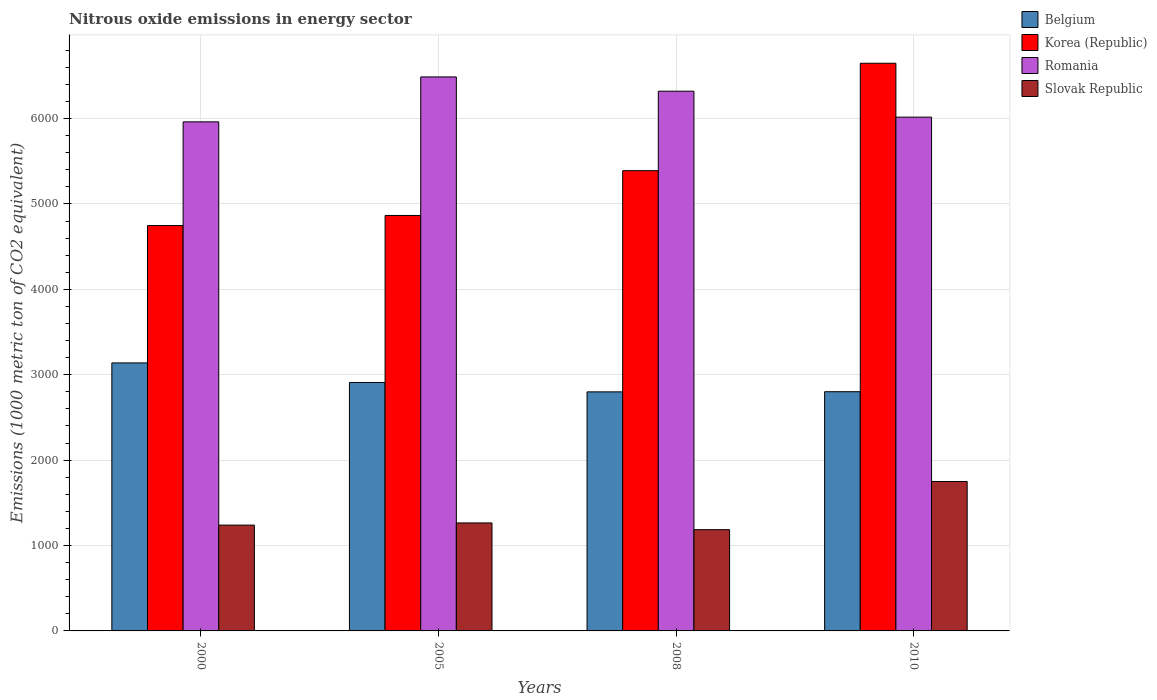Are the number of bars per tick equal to the number of legend labels?
Your response must be concise. Yes. How many bars are there on the 4th tick from the left?
Your answer should be compact. 4. How many bars are there on the 3rd tick from the right?
Provide a succinct answer. 4. What is the label of the 3rd group of bars from the left?
Your answer should be very brief. 2008. What is the amount of nitrous oxide emitted in Slovak Republic in 2000?
Offer a terse response. 1239.1. Across all years, what is the maximum amount of nitrous oxide emitted in Romania?
Your response must be concise. 6487.3. Across all years, what is the minimum amount of nitrous oxide emitted in Romania?
Offer a terse response. 5961.2. In which year was the amount of nitrous oxide emitted in Belgium maximum?
Offer a terse response. 2000. What is the total amount of nitrous oxide emitted in Belgium in the graph?
Your response must be concise. 1.16e+04. What is the difference between the amount of nitrous oxide emitted in Romania in 2000 and that in 2008?
Your answer should be compact. -358.9. What is the difference between the amount of nitrous oxide emitted in Slovak Republic in 2008 and the amount of nitrous oxide emitted in Belgium in 2000?
Make the answer very short. -1952.9. What is the average amount of nitrous oxide emitted in Slovak Republic per year?
Make the answer very short. 1359.7. In the year 2008, what is the difference between the amount of nitrous oxide emitted in Korea (Republic) and amount of nitrous oxide emitted in Belgium?
Your answer should be compact. 2590.3. In how many years, is the amount of nitrous oxide emitted in Korea (Republic) greater than 800 1000 metric ton?
Give a very brief answer. 4. What is the ratio of the amount of nitrous oxide emitted in Romania in 2000 to that in 2010?
Make the answer very short. 0.99. Is the difference between the amount of nitrous oxide emitted in Korea (Republic) in 2000 and 2008 greater than the difference between the amount of nitrous oxide emitted in Belgium in 2000 and 2008?
Make the answer very short. No. What is the difference between the highest and the second highest amount of nitrous oxide emitted in Korea (Republic)?
Make the answer very short. 1257.7. What is the difference between the highest and the lowest amount of nitrous oxide emitted in Slovak Republic?
Keep it short and to the point. 564.2. Is it the case that in every year, the sum of the amount of nitrous oxide emitted in Korea (Republic) and amount of nitrous oxide emitted in Belgium is greater than the sum of amount of nitrous oxide emitted in Slovak Republic and amount of nitrous oxide emitted in Romania?
Your answer should be very brief. Yes. What does the 1st bar from the left in 2008 represents?
Your response must be concise. Belgium. What does the 3rd bar from the right in 2008 represents?
Keep it short and to the point. Korea (Republic). Is it the case that in every year, the sum of the amount of nitrous oxide emitted in Romania and amount of nitrous oxide emitted in Belgium is greater than the amount of nitrous oxide emitted in Slovak Republic?
Give a very brief answer. Yes. How many bars are there?
Make the answer very short. 16. How many years are there in the graph?
Keep it short and to the point. 4. Are the values on the major ticks of Y-axis written in scientific E-notation?
Your response must be concise. No. Where does the legend appear in the graph?
Ensure brevity in your answer.  Top right. How many legend labels are there?
Provide a short and direct response. 4. What is the title of the graph?
Provide a short and direct response. Nitrous oxide emissions in energy sector. What is the label or title of the X-axis?
Your answer should be compact. Years. What is the label or title of the Y-axis?
Provide a succinct answer. Emissions (1000 metric ton of CO2 equivalent). What is the Emissions (1000 metric ton of CO2 equivalent) of Belgium in 2000?
Provide a short and direct response. 3138.4. What is the Emissions (1000 metric ton of CO2 equivalent) of Korea (Republic) in 2000?
Provide a succinct answer. 4746.8. What is the Emissions (1000 metric ton of CO2 equivalent) of Romania in 2000?
Your answer should be very brief. 5961.2. What is the Emissions (1000 metric ton of CO2 equivalent) in Slovak Republic in 2000?
Ensure brevity in your answer.  1239.1. What is the Emissions (1000 metric ton of CO2 equivalent) of Belgium in 2005?
Your answer should be compact. 2909.4. What is the Emissions (1000 metric ton of CO2 equivalent) of Korea (Republic) in 2005?
Your answer should be compact. 4865. What is the Emissions (1000 metric ton of CO2 equivalent) of Romania in 2005?
Keep it short and to the point. 6487.3. What is the Emissions (1000 metric ton of CO2 equivalent) in Slovak Republic in 2005?
Your response must be concise. 1264.5. What is the Emissions (1000 metric ton of CO2 equivalent) of Belgium in 2008?
Your answer should be compact. 2799.3. What is the Emissions (1000 metric ton of CO2 equivalent) in Korea (Republic) in 2008?
Provide a succinct answer. 5389.6. What is the Emissions (1000 metric ton of CO2 equivalent) of Romania in 2008?
Offer a terse response. 6320.1. What is the Emissions (1000 metric ton of CO2 equivalent) of Slovak Republic in 2008?
Offer a terse response. 1185.5. What is the Emissions (1000 metric ton of CO2 equivalent) of Belgium in 2010?
Your answer should be very brief. 2801.2. What is the Emissions (1000 metric ton of CO2 equivalent) in Korea (Republic) in 2010?
Give a very brief answer. 6647.3. What is the Emissions (1000 metric ton of CO2 equivalent) in Romania in 2010?
Your response must be concise. 6016.4. What is the Emissions (1000 metric ton of CO2 equivalent) in Slovak Republic in 2010?
Make the answer very short. 1749.7. Across all years, what is the maximum Emissions (1000 metric ton of CO2 equivalent) of Belgium?
Make the answer very short. 3138.4. Across all years, what is the maximum Emissions (1000 metric ton of CO2 equivalent) in Korea (Republic)?
Make the answer very short. 6647.3. Across all years, what is the maximum Emissions (1000 metric ton of CO2 equivalent) of Romania?
Provide a short and direct response. 6487.3. Across all years, what is the maximum Emissions (1000 metric ton of CO2 equivalent) of Slovak Republic?
Provide a succinct answer. 1749.7. Across all years, what is the minimum Emissions (1000 metric ton of CO2 equivalent) in Belgium?
Offer a terse response. 2799.3. Across all years, what is the minimum Emissions (1000 metric ton of CO2 equivalent) of Korea (Republic)?
Your answer should be compact. 4746.8. Across all years, what is the minimum Emissions (1000 metric ton of CO2 equivalent) in Romania?
Your answer should be compact. 5961.2. Across all years, what is the minimum Emissions (1000 metric ton of CO2 equivalent) of Slovak Republic?
Ensure brevity in your answer.  1185.5. What is the total Emissions (1000 metric ton of CO2 equivalent) of Belgium in the graph?
Offer a terse response. 1.16e+04. What is the total Emissions (1000 metric ton of CO2 equivalent) in Korea (Republic) in the graph?
Offer a terse response. 2.16e+04. What is the total Emissions (1000 metric ton of CO2 equivalent) in Romania in the graph?
Offer a terse response. 2.48e+04. What is the total Emissions (1000 metric ton of CO2 equivalent) of Slovak Republic in the graph?
Provide a short and direct response. 5438.8. What is the difference between the Emissions (1000 metric ton of CO2 equivalent) in Belgium in 2000 and that in 2005?
Your response must be concise. 229. What is the difference between the Emissions (1000 metric ton of CO2 equivalent) in Korea (Republic) in 2000 and that in 2005?
Your response must be concise. -118.2. What is the difference between the Emissions (1000 metric ton of CO2 equivalent) in Romania in 2000 and that in 2005?
Ensure brevity in your answer.  -526.1. What is the difference between the Emissions (1000 metric ton of CO2 equivalent) of Slovak Republic in 2000 and that in 2005?
Offer a very short reply. -25.4. What is the difference between the Emissions (1000 metric ton of CO2 equivalent) of Belgium in 2000 and that in 2008?
Offer a terse response. 339.1. What is the difference between the Emissions (1000 metric ton of CO2 equivalent) of Korea (Republic) in 2000 and that in 2008?
Your answer should be very brief. -642.8. What is the difference between the Emissions (1000 metric ton of CO2 equivalent) in Romania in 2000 and that in 2008?
Offer a very short reply. -358.9. What is the difference between the Emissions (1000 metric ton of CO2 equivalent) in Slovak Republic in 2000 and that in 2008?
Your response must be concise. 53.6. What is the difference between the Emissions (1000 metric ton of CO2 equivalent) in Belgium in 2000 and that in 2010?
Keep it short and to the point. 337.2. What is the difference between the Emissions (1000 metric ton of CO2 equivalent) of Korea (Republic) in 2000 and that in 2010?
Provide a succinct answer. -1900.5. What is the difference between the Emissions (1000 metric ton of CO2 equivalent) in Romania in 2000 and that in 2010?
Provide a short and direct response. -55.2. What is the difference between the Emissions (1000 metric ton of CO2 equivalent) of Slovak Republic in 2000 and that in 2010?
Make the answer very short. -510.6. What is the difference between the Emissions (1000 metric ton of CO2 equivalent) of Belgium in 2005 and that in 2008?
Make the answer very short. 110.1. What is the difference between the Emissions (1000 metric ton of CO2 equivalent) in Korea (Republic) in 2005 and that in 2008?
Provide a succinct answer. -524.6. What is the difference between the Emissions (1000 metric ton of CO2 equivalent) of Romania in 2005 and that in 2008?
Ensure brevity in your answer.  167.2. What is the difference between the Emissions (1000 metric ton of CO2 equivalent) in Slovak Republic in 2005 and that in 2008?
Your answer should be very brief. 79. What is the difference between the Emissions (1000 metric ton of CO2 equivalent) in Belgium in 2005 and that in 2010?
Provide a succinct answer. 108.2. What is the difference between the Emissions (1000 metric ton of CO2 equivalent) in Korea (Republic) in 2005 and that in 2010?
Offer a terse response. -1782.3. What is the difference between the Emissions (1000 metric ton of CO2 equivalent) in Romania in 2005 and that in 2010?
Ensure brevity in your answer.  470.9. What is the difference between the Emissions (1000 metric ton of CO2 equivalent) in Slovak Republic in 2005 and that in 2010?
Keep it short and to the point. -485.2. What is the difference between the Emissions (1000 metric ton of CO2 equivalent) in Belgium in 2008 and that in 2010?
Keep it short and to the point. -1.9. What is the difference between the Emissions (1000 metric ton of CO2 equivalent) of Korea (Republic) in 2008 and that in 2010?
Keep it short and to the point. -1257.7. What is the difference between the Emissions (1000 metric ton of CO2 equivalent) in Romania in 2008 and that in 2010?
Provide a succinct answer. 303.7. What is the difference between the Emissions (1000 metric ton of CO2 equivalent) in Slovak Republic in 2008 and that in 2010?
Provide a succinct answer. -564.2. What is the difference between the Emissions (1000 metric ton of CO2 equivalent) of Belgium in 2000 and the Emissions (1000 metric ton of CO2 equivalent) of Korea (Republic) in 2005?
Your answer should be compact. -1726.6. What is the difference between the Emissions (1000 metric ton of CO2 equivalent) in Belgium in 2000 and the Emissions (1000 metric ton of CO2 equivalent) in Romania in 2005?
Your answer should be very brief. -3348.9. What is the difference between the Emissions (1000 metric ton of CO2 equivalent) of Belgium in 2000 and the Emissions (1000 metric ton of CO2 equivalent) of Slovak Republic in 2005?
Your answer should be compact. 1873.9. What is the difference between the Emissions (1000 metric ton of CO2 equivalent) of Korea (Republic) in 2000 and the Emissions (1000 metric ton of CO2 equivalent) of Romania in 2005?
Provide a short and direct response. -1740.5. What is the difference between the Emissions (1000 metric ton of CO2 equivalent) in Korea (Republic) in 2000 and the Emissions (1000 metric ton of CO2 equivalent) in Slovak Republic in 2005?
Keep it short and to the point. 3482.3. What is the difference between the Emissions (1000 metric ton of CO2 equivalent) in Romania in 2000 and the Emissions (1000 metric ton of CO2 equivalent) in Slovak Republic in 2005?
Give a very brief answer. 4696.7. What is the difference between the Emissions (1000 metric ton of CO2 equivalent) in Belgium in 2000 and the Emissions (1000 metric ton of CO2 equivalent) in Korea (Republic) in 2008?
Offer a very short reply. -2251.2. What is the difference between the Emissions (1000 metric ton of CO2 equivalent) of Belgium in 2000 and the Emissions (1000 metric ton of CO2 equivalent) of Romania in 2008?
Offer a terse response. -3181.7. What is the difference between the Emissions (1000 metric ton of CO2 equivalent) in Belgium in 2000 and the Emissions (1000 metric ton of CO2 equivalent) in Slovak Republic in 2008?
Ensure brevity in your answer.  1952.9. What is the difference between the Emissions (1000 metric ton of CO2 equivalent) in Korea (Republic) in 2000 and the Emissions (1000 metric ton of CO2 equivalent) in Romania in 2008?
Give a very brief answer. -1573.3. What is the difference between the Emissions (1000 metric ton of CO2 equivalent) in Korea (Republic) in 2000 and the Emissions (1000 metric ton of CO2 equivalent) in Slovak Republic in 2008?
Offer a terse response. 3561.3. What is the difference between the Emissions (1000 metric ton of CO2 equivalent) in Romania in 2000 and the Emissions (1000 metric ton of CO2 equivalent) in Slovak Republic in 2008?
Provide a succinct answer. 4775.7. What is the difference between the Emissions (1000 metric ton of CO2 equivalent) in Belgium in 2000 and the Emissions (1000 metric ton of CO2 equivalent) in Korea (Republic) in 2010?
Give a very brief answer. -3508.9. What is the difference between the Emissions (1000 metric ton of CO2 equivalent) of Belgium in 2000 and the Emissions (1000 metric ton of CO2 equivalent) of Romania in 2010?
Give a very brief answer. -2878. What is the difference between the Emissions (1000 metric ton of CO2 equivalent) of Belgium in 2000 and the Emissions (1000 metric ton of CO2 equivalent) of Slovak Republic in 2010?
Your answer should be very brief. 1388.7. What is the difference between the Emissions (1000 metric ton of CO2 equivalent) of Korea (Republic) in 2000 and the Emissions (1000 metric ton of CO2 equivalent) of Romania in 2010?
Ensure brevity in your answer.  -1269.6. What is the difference between the Emissions (1000 metric ton of CO2 equivalent) of Korea (Republic) in 2000 and the Emissions (1000 metric ton of CO2 equivalent) of Slovak Republic in 2010?
Your response must be concise. 2997.1. What is the difference between the Emissions (1000 metric ton of CO2 equivalent) in Romania in 2000 and the Emissions (1000 metric ton of CO2 equivalent) in Slovak Republic in 2010?
Provide a short and direct response. 4211.5. What is the difference between the Emissions (1000 metric ton of CO2 equivalent) in Belgium in 2005 and the Emissions (1000 metric ton of CO2 equivalent) in Korea (Republic) in 2008?
Your response must be concise. -2480.2. What is the difference between the Emissions (1000 metric ton of CO2 equivalent) of Belgium in 2005 and the Emissions (1000 metric ton of CO2 equivalent) of Romania in 2008?
Make the answer very short. -3410.7. What is the difference between the Emissions (1000 metric ton of CO2 equivalent) of Belgium in 2005 and the Emissions (1000 metric ton of CO2 equivalent) of Slovak Republic in 2008?
Your response must be concise. 1723.9. What is the difference between the Emissions (1000 metric ton of CO2 equivalent) of Korea (Republic) in 2005 and the Emissions (1000 metric ton of CO2 equivalent) of Romania in 2008?
Your answer should be compact. -1455.1. What is the difference between the Emissions (1000 metric ton of CO2 equivalent) of Korea (Republic) in 2005 and the Emissions (1000 metric ton of CO2 equivalent) of Slovak Republic in 2008?
Ensure brevity in your answer.  3679.5. What is the difference between the Emissions (1000 metric ton of CO2 equivalent) of Romania in 2005 and the Emissions (1000 metric ton of CO2 equivalent) of Slovak Republic in 2008?
Make the answer very short. 5301.8. What is the difference between the Emissions (1000 metric ton of CO2 equivalent) of Belgium in 2005 and the Emissions (1000 metric ton of CO2 equivalent) of Korea (Republic) in 2010?
Ensure brevity in your answer.  -3737.9. What is the difference between the Emissions (1000 metric ton of CO2 equivalent) of Belgium in 2005 and the Emissions (1000 metric ton of CO2 equivalent) of Romania in 2010?
Provide a succinct answer. -3107. What is the difference between the Emissions (1000 metric ton of CO2 equivalent) of Belgium in 2005 and the Emissions (1000 metric ton of CO2 equivalent) of Slovak Republic in 2010?
Keep it short and to the point. 1159.7. What is the difference between the Emissions (1000 metric ton of CO2 equivalent) in Korea (Republic) in 2005 and the Emissions (1000 metric ton of CO2 equivalent) in Romania in 2010?
Keep it short and to the point. -1151.4. What is the difference between the Emissions (1000 metric ton of CO2 equivalent) in Korea (Republic) in 2005 and the Emissions (1000 metric ton of CO2 equivalent) in Slovak Republic in 2010?
Provide a short and direct response. 3115.3. What is the difference between the Emissions (1000 metric ton of CO2 equivalent) of Romania in 2005 and the Emissions (1000 metric ton of CO2 equivalent) of Slovak Republic in 2010?
Make the answer very short. 4737.6. What is the difference between the Emissions (1000 metric ton of CO2 equivalent) in Belgium in 2008 and the Emissions (1000 metric ton of CO2 equivalent) in Korea (Republic) in 2010?
Give a very brief answer. -3848. What is the difference between the Emissions (1000 metric ton of CO2 equivalent) in Belgium in 2008 and the Emissions (1000 metric ton of CO2 equivalent) in Romania in 2010?
Keep it short and to the point. -3217.1. What is the difference between the Emissions (1000 metric ton of CO2 equivalent) of Belgium in 2008 and the Emissions (1000 metric ton of CO2 equivalent) of Slovak Republic in 2010?
Your response must be concise. 1049.6. What is the difference between the Emissions (1000 metric ton of CO2 equivalent) in Korea (Republic) in 2008 and the Emissions (1000 metric ton of CO2 equivalent) in Romania in 2010?
Offer a terse response. -626.8. What is the difference between the Emissions (1000 metric ton of CO2 equivalent) of Korea (Republic) in 2008 and the Emissions (1000 metric ton of CO2 equivalent) of Slovak Republic in 2010?
Your answer should be compact. 3639.9. What is the difference between the Emissions (1000 metric ton of CO2 equivalent) in Romania in 2008 and the Emissions (1000 metric ton of CO2 equivalent) in Slovak Republic in 2010?
Your answer should be compact. 4570.4. What is the average Emissions (1000 metric ton of CO2 equivalent) in Belgium per year?
Your answer should be compact. 2912.07. What is the average Emissions (1000 metric ton of CO2 equivalent) of Korea (Republic) per year?
Ensure brevity in your answer.  5412.18. What is the average Emissions (1000 metric ton of CO2 equivalent) in Romania per year?
Provide a succinct answer. 6196.25. What is the average Emissions (1000 metric ton of CO2 equivalent) in Slovak Republic per year?
Offer a very short reply. 1359.7. In the year 2000, what is the difference between the Emissions (1000 metric ton of CO2 equivalent) in Belgium and Emissions (1000 metric ton of CO2 equivalent) in Korea (Republic)?
Your answer should be very brief. -1608.4. In the year 2000, what is the difference between the Emissions (1000 metric ton of CO2 equivalent) in Belgium and Emissions (1000 metric ton of CO2 equivalent) in Romania?
Your response must be concise. -2822.8. In the year 2000, what is the difference between the Emissions (1000 metric ton of CO2 equivalent) in Belgium and Emissions (1000 metric ton of CO2 equivalent) in Slovak Republic?
Your answer should be very brief. 1899.3. In the year 2000, what is the difference between the Emissions (1000 metric ton of CO2 equivalent) of Korea (Republic) and Emissions (1000 metric ton of CO2 equivalent) of Romania?
Your response must be concise. -1214.4. In the year 2000, what is the difference between the Emissions (1000 metric ton of CO2 equivalent) of Korea (Republic) and Emissions (1000 metric ton of CO2 equivalent) of Slovak Republic?
Your answer should be compact. 3507.7. In the year 2000, what is the difference between the Emissions (1000 metric ton of CO2 equivalent) in Romania and Emissions (1000 metric ton of CO2 equivalent) in Slovak Republic?
Make the answer very short. 4722.1. In the year 2005, what is the difference between the Emissions (1000 metric ton of CO2 equivalent) in Belgium and Emissions (1000 metric ton of CO2 equivalent) in Korea (Republic)?
Give a very brief answer. -1955.6. In the year 2005, what is the difference between the Emissions (1000 metric ton of CO2 equivalent) in Belgium and Emissions (1000 metric ton of CO2 equivalent) in Romania?
Ensure brevity in your answer.  -3577.9. In the year 2005, what is the difference between the Emissions (1000 metric ton of CO2 equivalent) of Belgium and Emissions (1000 metric ton of CO2 equivalent) of Slovak Republic?
Provide a succinct answer. 1644.9. In the year 2005, what is the difference between the Emissions (1000 metric ton of CO2 equivalent) of Korea (Republic) and Emissions (1000 metric ton of CO2 equivalent) of Romania?
Ensure brevity in your answer.  -1622.3. In the year 2005, what is the difference between the Emissions (1000 metric ton of CO2 equivalent) in Korea (Republic) and Emissions (1000 metric ton of CO2 equivalent) in Slovak Republic?
Offer a terse response. 3600.5. In the year 2005, what is the difference between the Emissions (1000 metric ton of CO2 equivalent) of Romania and Emissions (1000 metric ton of CO2 equivalent) of Slovak Republic?
Make the answer very short. 5222.8. In the year 2008, what is the difference between the Emissions (1000 metric ton of CO2 equivalent) of Belgium and Emissions (1000 metric ton of CO2 equivalent) of Korea (Republic)?
Keep it short and to the point. -2590.3. In the year 2008, what is the difference between the Emissions (1000 metric ton of CO2 equivalent) in Belgium and Emissions (1000 metric ton of CO2 equivalent) in Romania?
Keep it short and to the point. -3520.8. In the year 2008, what is the difference between the Emissions (1000 metric ton of CO2 equivalent) of Belgium and Emissions (1000 metric ton of CO2 equivalent) of Slovak Republic?
Your answer should be compact. 1613.8. In the year 2008, what is the difference between the Emissions (1000 metric ton of CO2 equivalent) of Korea (Republic) and Emissions (1000 metric ton of CO2 equivalent) of Romania?
Your answer should be very brief. -930.5. In the year 2008, what is the difference between the Emissions (1000 metric ton of CO2 equivalent) in Korea (Republic) and Emissions (1000 metric ton of CO2 equivalent) in Slovak Republic?
Keep it short and to the point. 4204.1. In the year 2008, what is the difference between the Emissions (1000 metric ton of CO2 equivalent) of Romania and Emissions (1000 metric ton of CO2 equivalent) of Slovak Republic?
Ensure brevity in your answer.  5134.6. In the year 2010, what is the difference between the Emissions (1000 metric ton of CO2 equivalent) of Belgium and Emissions (1000 metric ton of CO2 equivalent) of Korea (Republic)?
Your answer should be very brief. -3846.1. In the year 2010, what is the difference between the Emissions (1000 metric ton of CO2 equivalent) of Belgium and Emissions (1000 metric ton of CO2 equivalent) of Romania?
Your answer should be very brief. -3215.2. In the year 2010, what is the difference between the Emissions (1000 metric ton of CO2 equivalent) of Belgium and Emissions (1000 metric ton of CO2 equivalent) of Slovak Republic?
Keep it short and to the point. 1051.5. In the year 2010, what is the difference between the Emissions (1000 metric ton of CO2 equivalent) in Korea (Republic) and Emissions (1000 metric ton of CO2 equivalent) in Romania?
Your answer should be very brief. 630.9. In the year 2010, what is the difference between the Emissions (1000 metric ton of CO2 equivalent) of Korea (Republic) and Emissions (1000 metric ton of CO2 equivalent) of Slovak Republic?
Give a very brief answer. 4897.6. In the year 2010, what is the difference between the Emissions (1000 metric ton of CO2 equivalent) of Romania and Emissions (1000 metric ton of CO2 equivalent) of Slovak Republic?
Keep it short and to the point. 4266.7. What is the ratio of the Emissions (1000 metric ton of CO2 equivalent) in Belgium in 2000 to that in 2005?
Make the answer very short. 1.08. What is the ratio of the Emissions (1000 metric ton of CO2 equivalent) of Korea (Republic) in 2000 to that in 2005?
Provide a succinct answer. 0.98. What is the ratio of the Emissions (1000 metric ton of CO2 equivalent) in Romania in 2000 to that in 2005?
Your response must be concise. 0.92. What is the ratio of the Emissions (1000 metric ton of CO2 equivalent) in Slovak Republic in 2000 to that in 2005?
Offer a terse response. 0.98. What is the ratio of the Emissions (1000 metric ton of CO2 equivalent) in Belgium in 2000 to that in 2008?
Give a very brief answer. 1.12. What is the ratio of the Emissions (1000 metric ton of CO2 equivalent) of Korea (Republic) in 2000 to that in 2008?
Offer a very short reply. 0.88. What is the ratio of the Emissions (1000 metric ton of CO2 equivalent) in Romania in 2000 to that in 2008?
Your answer should be very brief. 0.94. What is the ratio of the Emissions (1000 metric ton of CO2 equivalent) in Slovak Republic in 2000 to that in 2008?
Keep it short and to the point. 1.05. What is the ratio of the Emissions (1000 metric ton of CO2 equivalent) in Belgium in 2000 to that in 2010?
Ensure brevity in your answer.  1.12. What is the ratio of the Emissions (1000 metric ton of CO2 equivalent) of Korea (Republic) in 2000 to that in 2010?
Your response must be concise. 0.71. What is the ratio of the Emissions (1000 metric ton of CO2 equivalent) of Slovak Republic in 2000 to that in 2010?
Your response must be concise. 0.71. What is the ratio of the Emissions (1000 metric ton of CO2 equivalent) in Belgium in 2005 to that in 2008?
Your answer should be compact. 1.04. What is the ratio of the Emissions (1000 metric ton of CO2 equivalent) of Korea (Republic) in 2005 to that in 2008?
Ensure brevity in your answer.  0.9. What is the ratio of the Emissions (1000 metric ton of CO2 equivalent) of Romania in 2005 to that in 2008?
Provide a succinct answer. 1.03. What is the ratio of the Emissions (1000 metric ton of CO2 equivalent) of Slovak Republic in 2005 to that in 2008?
Offer a terse response. 1.07. What is the ratio of the Emissions (1000 metric ton of CO2 equivalent) of Belgium in 2005 to that in 2010?
Ensure brevity in your answer.  1.04. What is the ratio of the Emissions (1000 metric ton of CO2 equivalent) in Korea (Republic) in 2005 to that in 2010?
Keep it short and to the point. 0.73. What is the ratio of the Emissions (1000 metric ton of CO2 equivalent) of Romania in 2005 to that in 2010?
Ensure brevity in your answer.  1.08. What is the ratio of the Emissions (1000 metric ton of CO2 equivalent) of Slovak Republic in 2005 to that in 2010?
Keep it short and to the point. 0.72. What is the ratio of the Emissions (1000 metric ton of CO2 equivalent) in Korea (Republic) in 2008 to that in 2010?
Your answer should be compact. 0.81. What is the ratio of the Emissions (1000 metric ton of CO2 equivalent) of Romania in 2008 to that in 2010?
Provide a short and direct response. 1.05. What is the ratio of the Emissions (1000 metric ton of CO2 equivalent) in Slovak Republic in 2008 to that in 2010?
Your answer should be compact. 0.68. What is the difference between the highest and the second highest Emissions (1000 metric ton of CO2 equivalent) in Belgium?
Your answer should be compact. 229. What is the difference between the highest and the second highest Emissions (1000 metric ton of CO2 equivalent) in Korea (Republic)?
Offer a very short reply. 1257.7. What is the difference between the highest and the second highest Emissions (1000 metric ton of CO2 equivalent) of Romania?
Provide a succinct answer. 167.2. What is the difference between the highest and the second highest Emissions (1000 metric ton of CO2 equivalent) of Slovak Republic?
Make the answer very short. 485.2. What is the difference between the highest and the lowest Emissions (1000 metric ton of CO2 equivalent) of Belgium?
Your answer should be compact. 339.1. What is the difference between the highest and the lowest Emissions (1000 metric ton of CO2 equivalent) in Korea (Republic)?
Ensure brevity in your answer.  1900.5. What is the difference between the highest and the lowest Emissions (1000 metric ton of CO2 equivalent) of Romania?
Your response must be concise. 526.1. What is the difference between the highest and the lowest Emissions (1000 metric ton of CO2 equivalent) of Slovak Republic?
Make the answer very short. 564.2. 